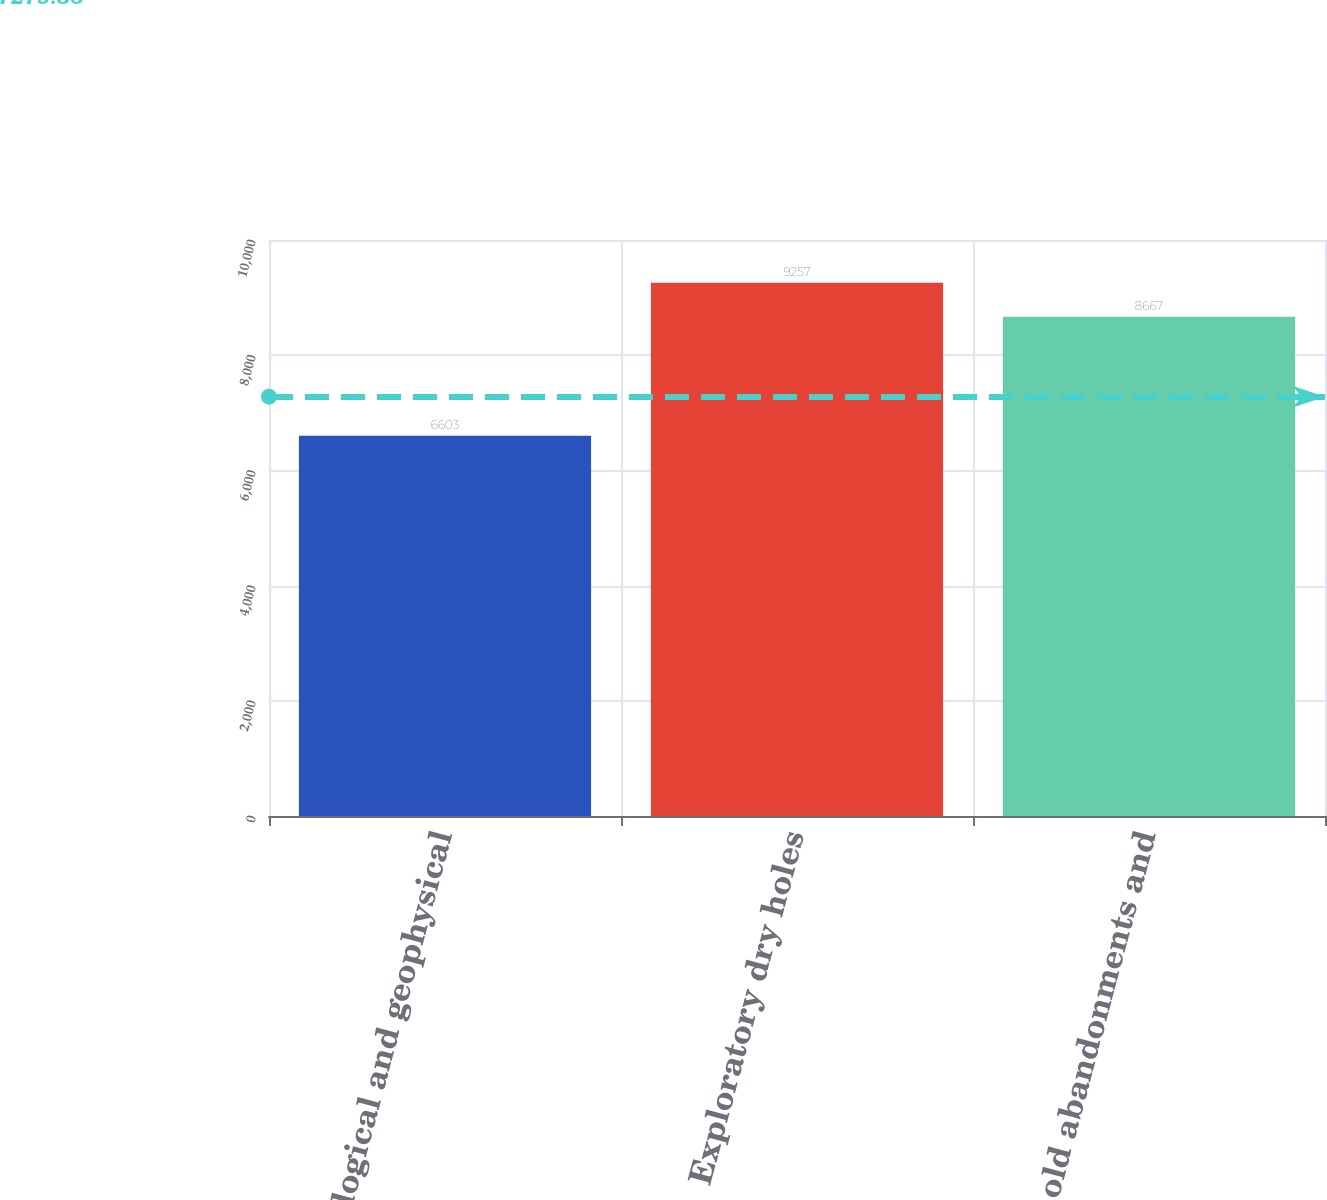Convert chart to OTSL. <chart><loc_0><loc_0><loc_500><loc_500><bar_chart><fcel>Geological and geophysical<fcel>Exploratory dry holes<fcel>Leasehold abandonments and<nl><fcel>6603<fcel>9257<fcel>8667<nl></chart> 